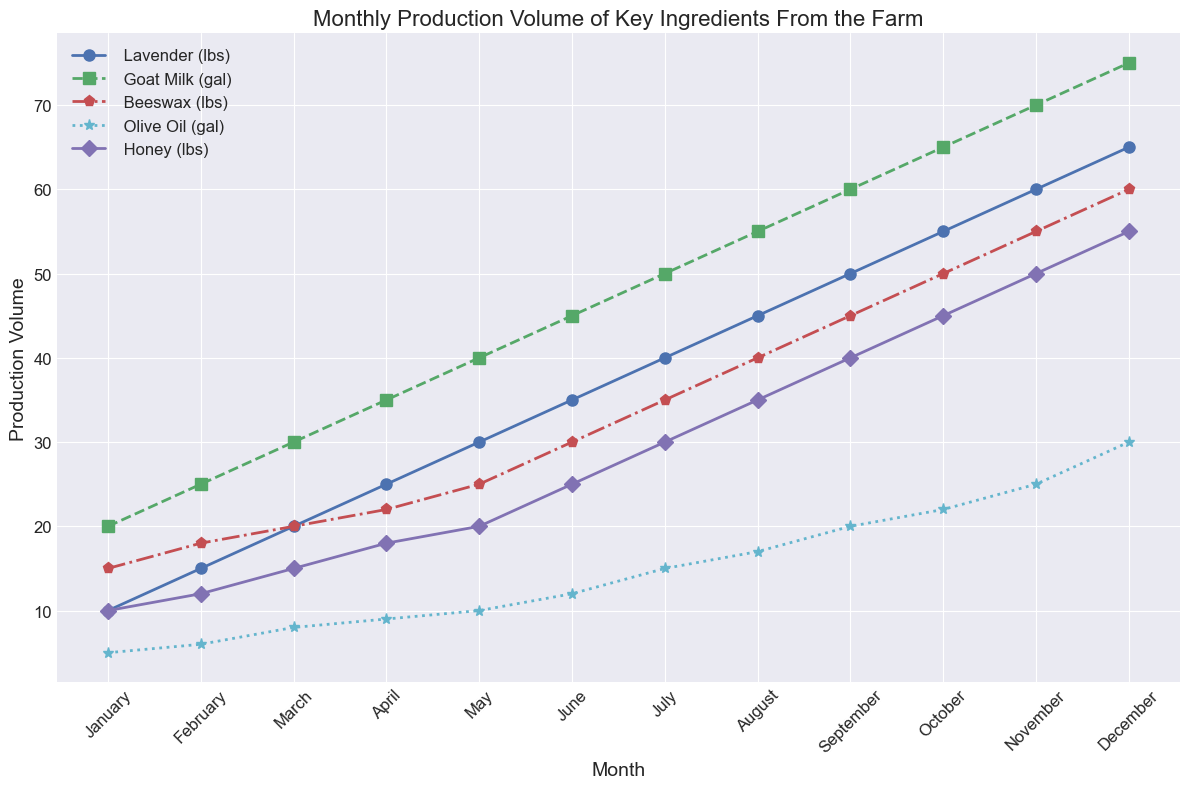What is the total production of Lavender in March and April combined? The production of Lavender in March is 20 lbs and in April is 25 lbs. Adding these together gives 20 + 25 = 45 lbs.
Answer: 45 lbs Which ingredient saw the highest increase in production volume from June to July? Comparing the production volumes of all ingredients from June to July, Lavender increases from 35 to 40 lbs (+5 lbs), Goat Milk from 45 to 50 gal (+5 gal), Beeswax from 30 to 35 lbs (+5 lbs), Olive Oil from 12 to 15 gal (+3 gal), and Honey from 25 to 30 lbs (+5 lbs). Lavender, Goat Milk, Beeswax, and Honey all increased by 5 units.
Answer: Lavender, Goat Milk, Beeswax, Honey At which month do all ingredients experience the highest production volume? Observing the lines, all ingredients reach their maximum production volume in December.
Answer: December How does the production of Goat Milk compare to Olive Oil in October? In October, the production volume of Goat Milk is 65 gal, while Olive Oil is 22 gal. Goat Milk has a higher production volume.
Answer: Goat Milk > Olive Oil What is the average monthly production of Beeswax over the first quarter (January to March)? The production of Beeswax is 15 lbs in January, 18 lbs in February, and 20 lbs in March. The average is (15 + 18 + 20) / 3 = 17.67 lbs.
Answer: 17.67 lbs Which ingredient has the least production volume in February? In February, the production volumes are Lavender (15 lbs), Goat Milk (25 gal), Beeswax (18 lbs), Olive Oil (6 gal), Honey (12 lbs). Olive Oil has the least production volume at 6 gallons.
Answer: Olive Oil What is the rate of increase in Honey production from August to December? (in lbs per month) The production of Honey in August is 35 lbs and in December is 55 lbs. The number of months between August and December is 4. The rate of increase is (55 - 35) / 4 = 5 lbs per month.
Answer: 5 lbs per month Which two months have the same production volume for any ingredient? Observing the lines, April and May both have the same production volume of 9 gallons for Olive Oil.
Answer: April and May Does the production of any ingredient decrease at any point during the year? By examining the trend lines, there are no points where any of the ingredients' production volumes decrease; all are increasing over the months.
Answer: No What is the difference between the production volumes of Honey and Beeswax in July? In July, Honey production is 30 lbs and Beeswax production is 35 lbs. The difference is 35 - 30 = 5 lbs.
Answer: 5 lbs 